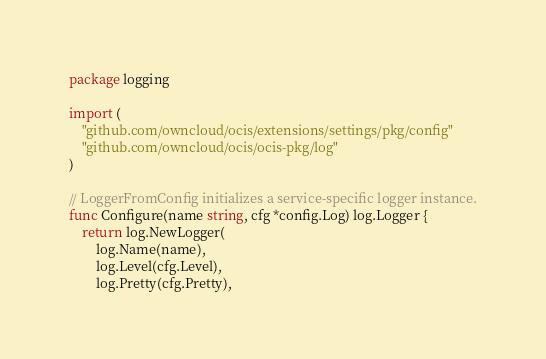<code> <loc_0><loc_0><loc_500><loc_500><_Go_>package logging

import (
	"github.com/owncloud/ocis/extensions/settings/pkg/config"
	"github.com/owncloud/ocis/ocis-pkg/log"
)

// LoggerFromConfig initializes a service-specific logger instance.
func Configure(name string, cfg *config.Log) log.Logger {
	return log.NewLogger(
		log.Name(name),
		log.Level(cfg.Level),
		log.Pretty(cfg.Pretty),</code> 